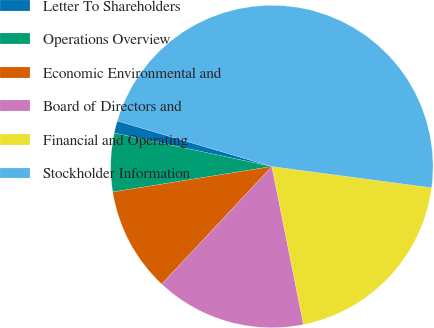Convert chart to OTSL. <chart><loc_0><loc_0><loc_500><loc_500><pie_chart><fcel>Letter To Shareholders<fcel>Operations Overview<fcel>Economic Environmental and<fcel>Board of Directors and<fcel>Financial and Operating<fcel>Stockholder Information<nl><fcel>1.23%<fcel>5.86%<fcel>10.49%<fcel>15.12%<fcel>19.75%<fcel>47.53%<nl></chart> 